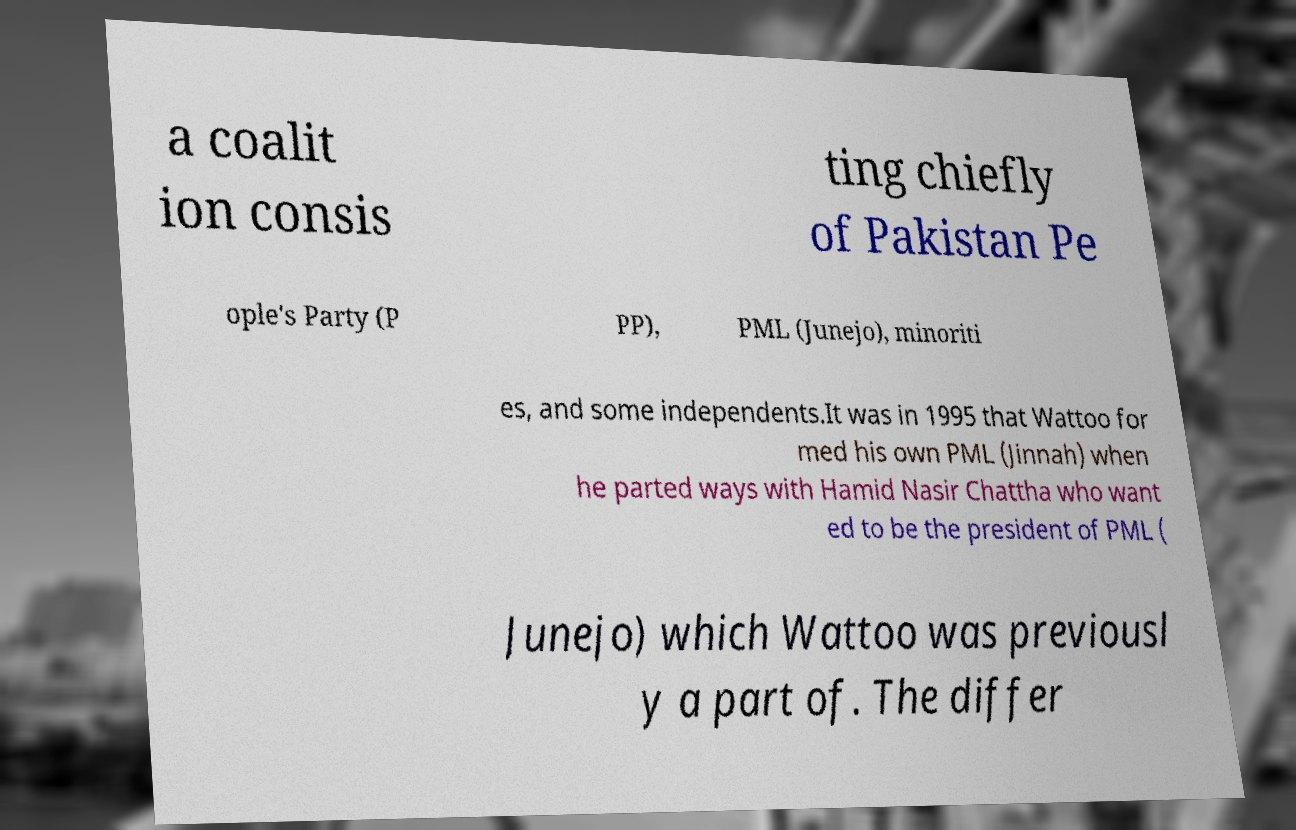Please identify and transcribe the text found in this image. a coalit ion consis ting chiefly of Pakistan Pe ople's Party (P PP), PML (Junejo), minoriti es, and some independents.It was in 1995 that Wattoo for med his own PML (Jinnah) when he parted ways with Hamid Nasir Chattha who want ed to be the president of PML ( Junejo) which Wattoo was previousl y a part of. The differ 